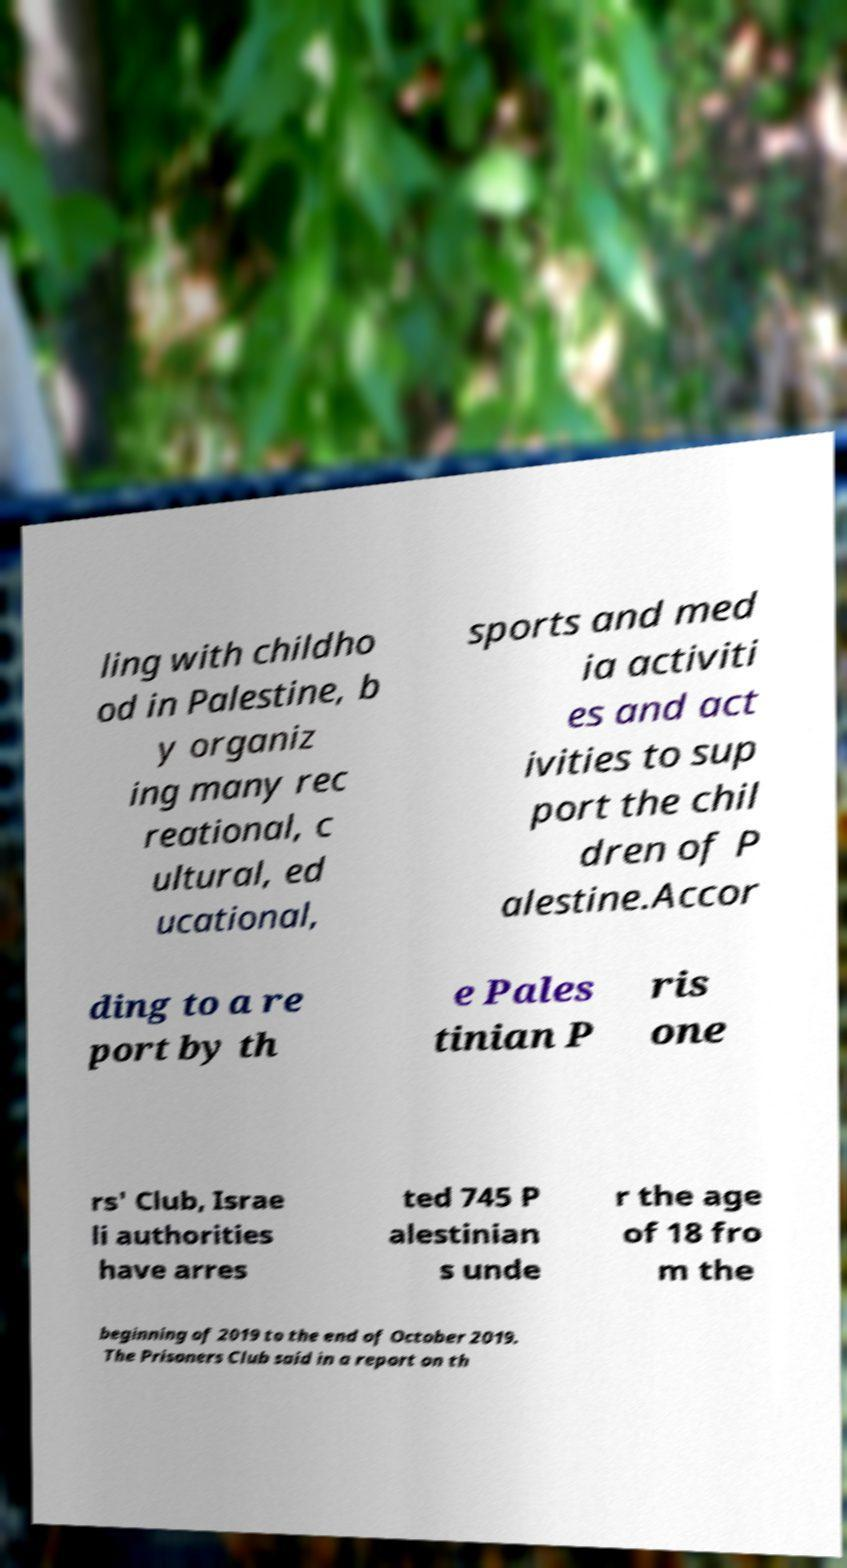Can you accurately transcribe the text from the provided image for me? ling with childho od in Palestine, b y organiz ing many rec reational, c ultural, ed ucational, sports and med ia activiti es and act ivities to sup port the chil dren of P alestine.Accor ding to a re port by th e Pales tinian P ris one rs' Club, Israe li authorities have arres ted 745 P alestinian s unde r the age of 18 fro m the beginning of 2019 to the end of October 2019. The Prisoners Club said in a report on th 